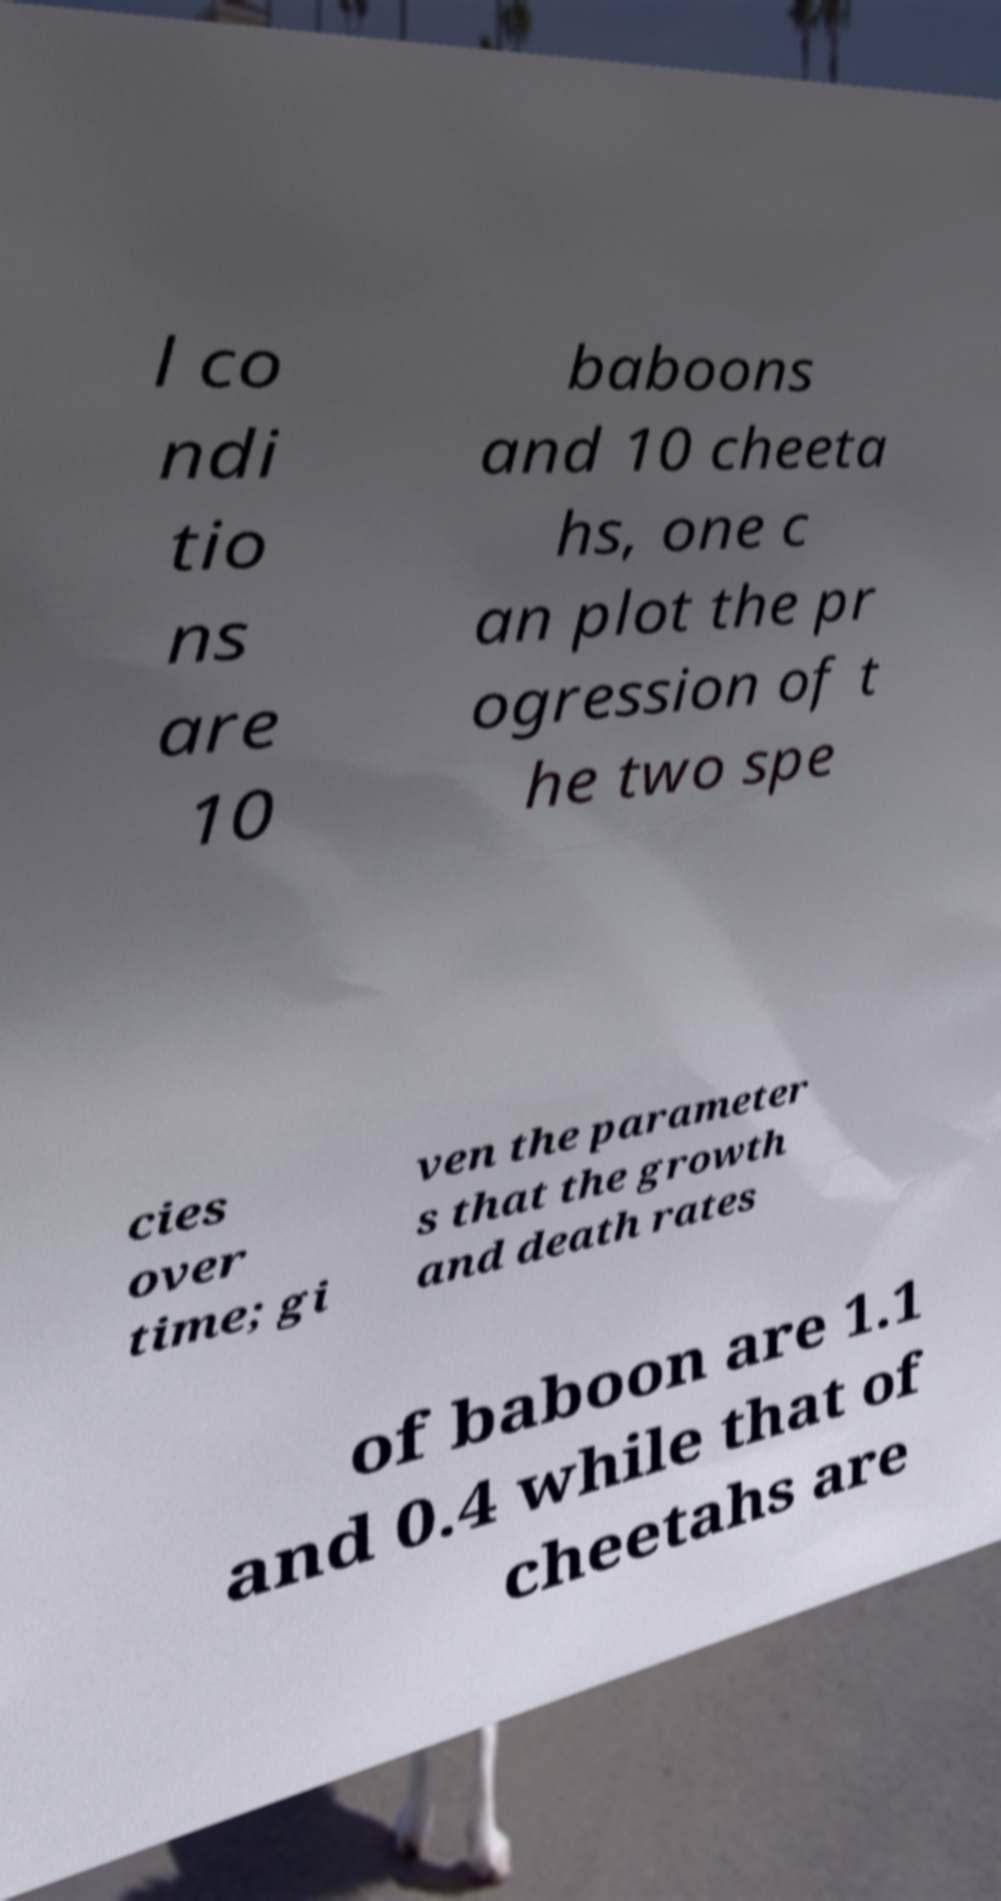There's text embedded in this image that I need extracted. Can you transcribe it verbatim? l co ndi tio ns are 10 baboons and 10 cheeta hs, one c an plot the pr ogression of t he two spe cies over time; gi ven the parameter s that the growth and death rates of baboon are 1.1 and 0.4 while that of cheetahs are 